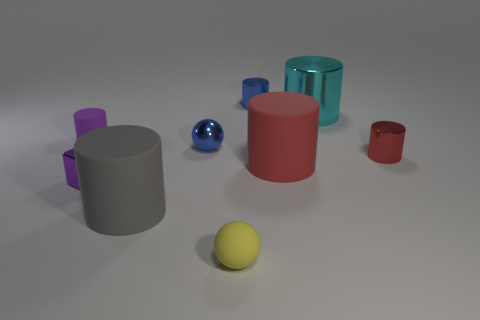Do the blue object to the right of the shiny ball and the tiny blue sphere have the same size?
Provide a succinct answer. Yes. How many large red rubber cylinders are there?
Your answer should be compact. 1. What number of tiny objects are both behind the tiny shiny block and to the left of the cyan object?
Offer a very short reply. 3. Are there any cubes that have the same material as the tiny yellow ball?
Your response must be concise. No. What is the material of the purple thing that is behind the small purple metallic cube that is on the right side of the tiny matte cylinder?
Give a very brief answer. Rubber. Are there an equal number of objects that are behind the red matte cylinder and big red cylinders that are behind the cyan cylinder?
Offer a very short reply. No. Do the cyan thing and the large gray rubber object have the same shape?
Your answer should be compact. Yes. What is the material of the small thing that is both to the right of the tiny purple metal object and on the left side of the rubber sphere?
Offer a very short reply. Metal. What number of large green rubber objects are the same shape as the red rubber object?
Offer a terse response. 0. What is the size of the blue shiny object that is on the left side of the tiny blue metal object behind the tiny cylinder on the left side of the gray rubber cylinder?
Offer a terse response. Small. 